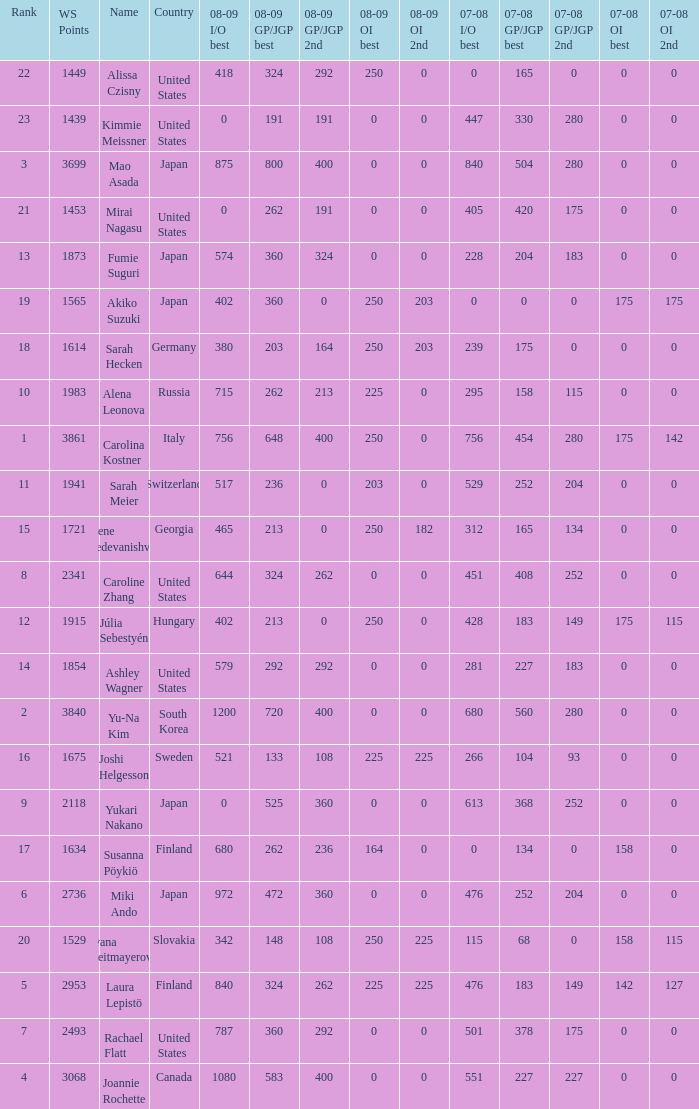08-09 gp/jgp 2nd is 213 and ws points will be what maximum 1983.0. 